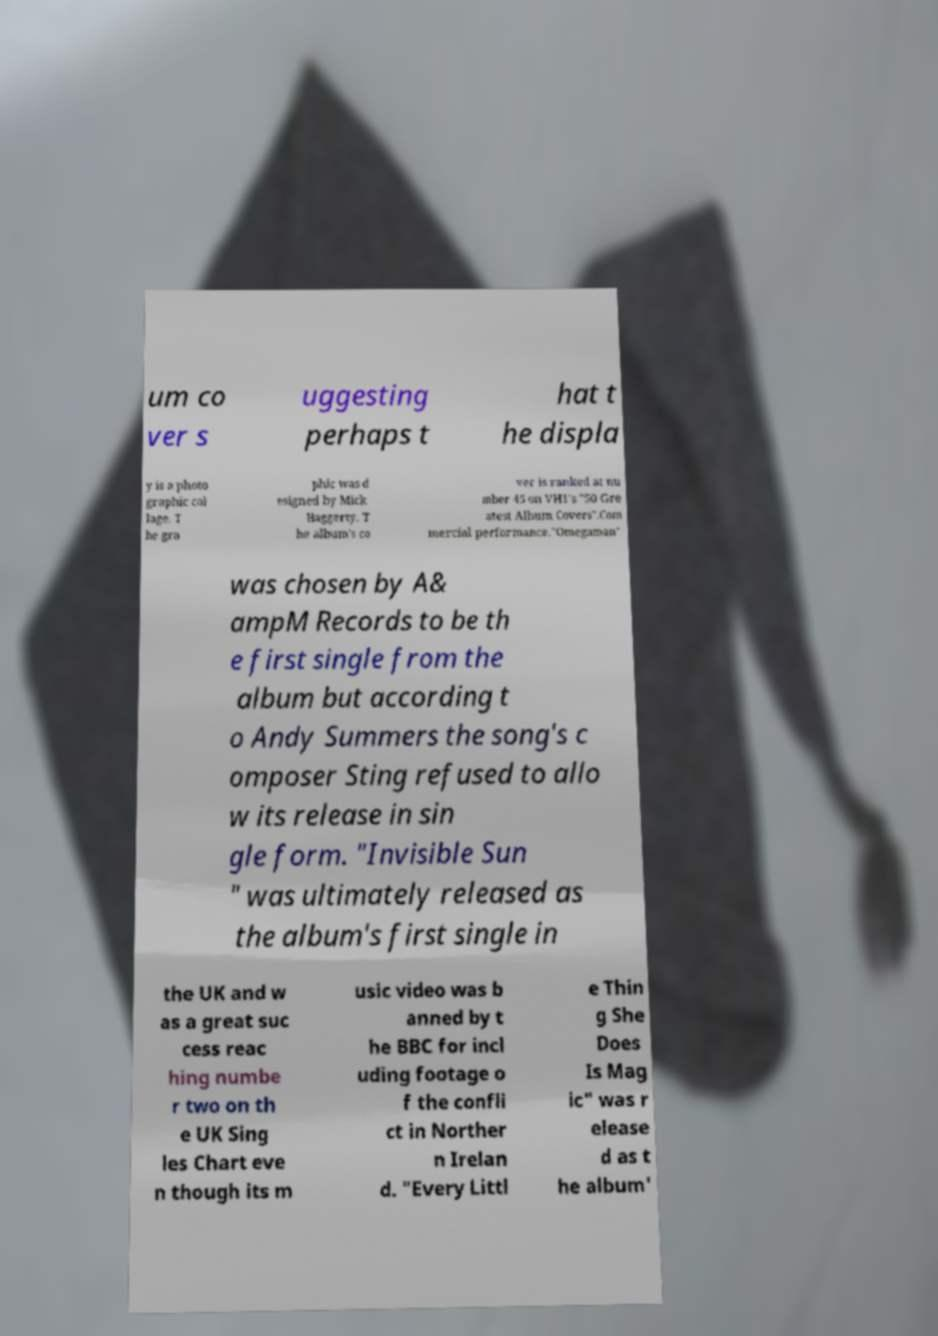Please read and relay the text visible in this image. What does it say? um co ver s uggesting perhaps t hat t he displa y is a photo graphic col lage. T he gra phic was d esigned by Mick Haggerty. T he album's co ver is ranked at nu mber 45 on VH1's "50 Gre atest Album Covers".Com mercial performance."Omegaman" was chosen by A& ampM Records to be th e first single from the album but according t o Andy Summers the song's c omposer Sting refused to allo w its release in sin gle form. "Invisible Sun " was ultimately released as the album's first single in the UK and w as a great suc cess reac hing numbe r two on th e UK Sing les Chart eve n though its m usic video was b anned by t he BBC for incl uding footage o f the confli ct in Norther n Irelan d. "Every Littl e Thin g She Does Is Mag ic" was r elease d as t he album' 